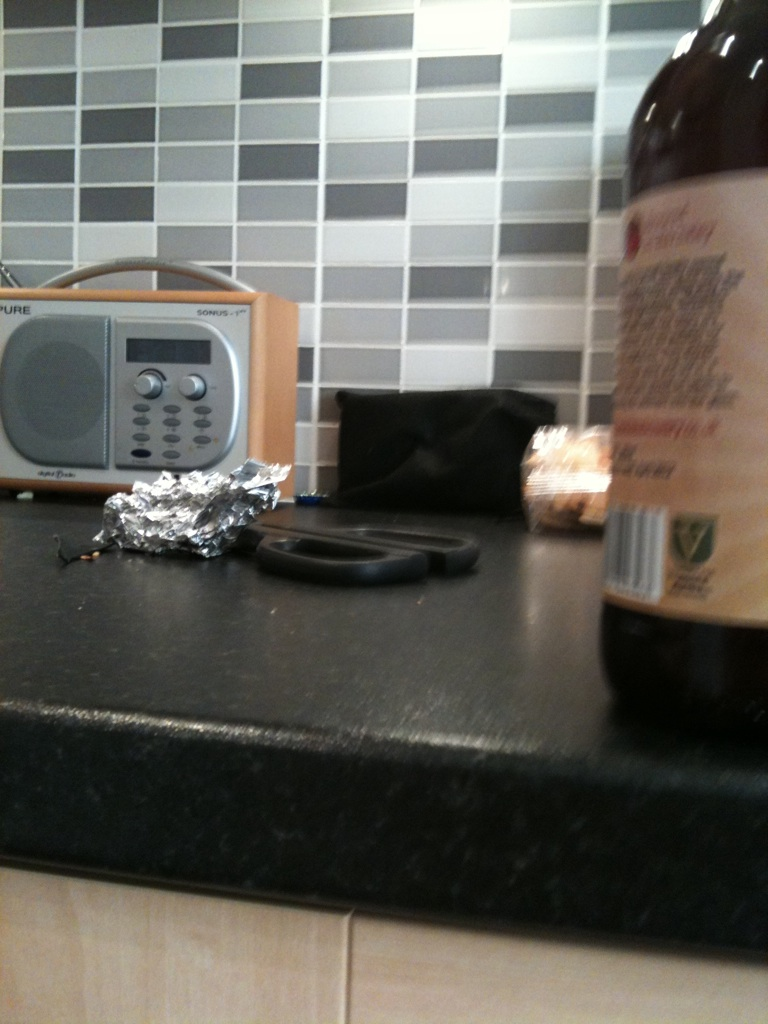Can you describe the overall setting or theme based on the elements shown in the image? The image depicts a home kitchen counter with various daily use items, suggesting an everyday domestic scene. It showcases typical kitchen items which indicate that it might be a setting where cooking or food preparation takes place regularly. 